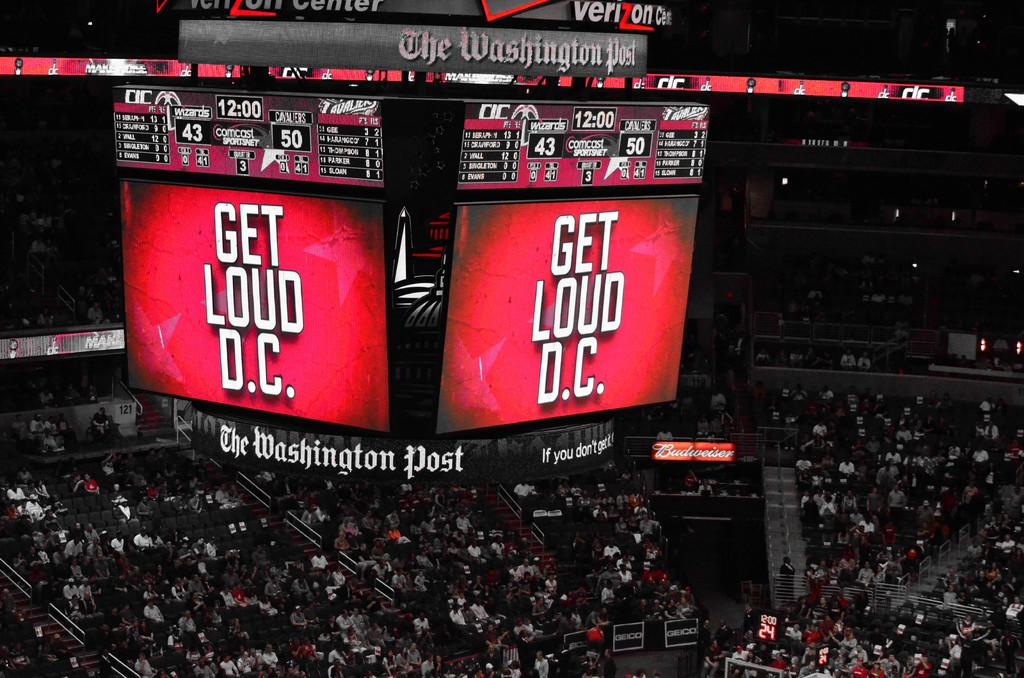Provide a one-sentence caption for the provided image. A Jumbotron in an arena that says Get Loud DC. 